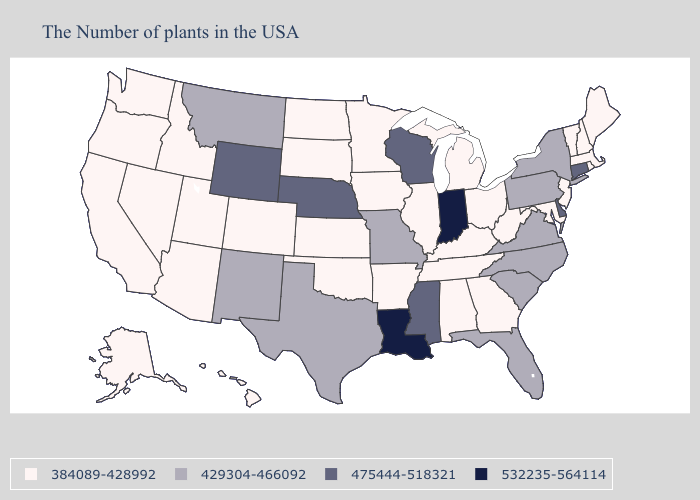Does Nebraska have the lowest value in the USA?
Write a very short answer. No. Name the states that have a value in the range 532235-564114?
Short answer required. Indiana, Louisiana. Does Indiana have the highest value in the USA?
Give a very brief answer. Yes. Name the states that have a value in the range 475444-518321?
Answer briefly. Connecticut, Delaware, Wisconsin, Mississippi, Nebraska, Wyoming. Does Minnesota have the highest value in the MidWest?
Write a very short answer. No. Does West Virginia have the highest value in the USA?
Quick response, please. No. Does New Hampshire have the highest value in the Northeast?
Concise answer only. No. What is the value of Connecticut?
Give a very brief answer. 475444-518321. What is the value of Washington?
Be succinct. 384089-428992. What is the value of Texas?
Give a very brief answer. 429304-466092. Name the states that have a value in the range 384089-428992?
Keep it brief. Maine, Massachusetts, Rhode Island, New Hampshire, Vermont, New Jersey, Maryland, West Virginia, Ohio, Georgia, Michigan, Kentucky, Alabama, Tennessee, Illinois, Arkansas, Minnesota, Iowa, Kansas, Oklahoma, South Dakota, North Dakota, Colorado, Utah, Arizona, Idaho, Nevada, California, Washington, Oregon, Alaska, Hawaii. Does Ohio have the highest value in the USA?
Quick response, please. No. What is the highest value in the USA?
Keep it brief. 532235-564114. Among the states that border Idaho , does Nevada have the highest value?
Answer briefly. No. Which states have the lowest value in the USA?
Answer briefly. Maine, Massachusetts, Rhode Island, New Hampshire, Vermont, New Jersey, Maryland, West Virginia, Ohio, Georgia, Michigan, Kentucky, Alabama, Tennessee, Illinois, Arkansas, Minnesota, Iowa, Kansas, Oklahoma, South Dakota, North Dakota, Colorado, Utah, Arizona, Idaho, Nevada, California, Washington, Oregon, Alaska, Hawaii. 